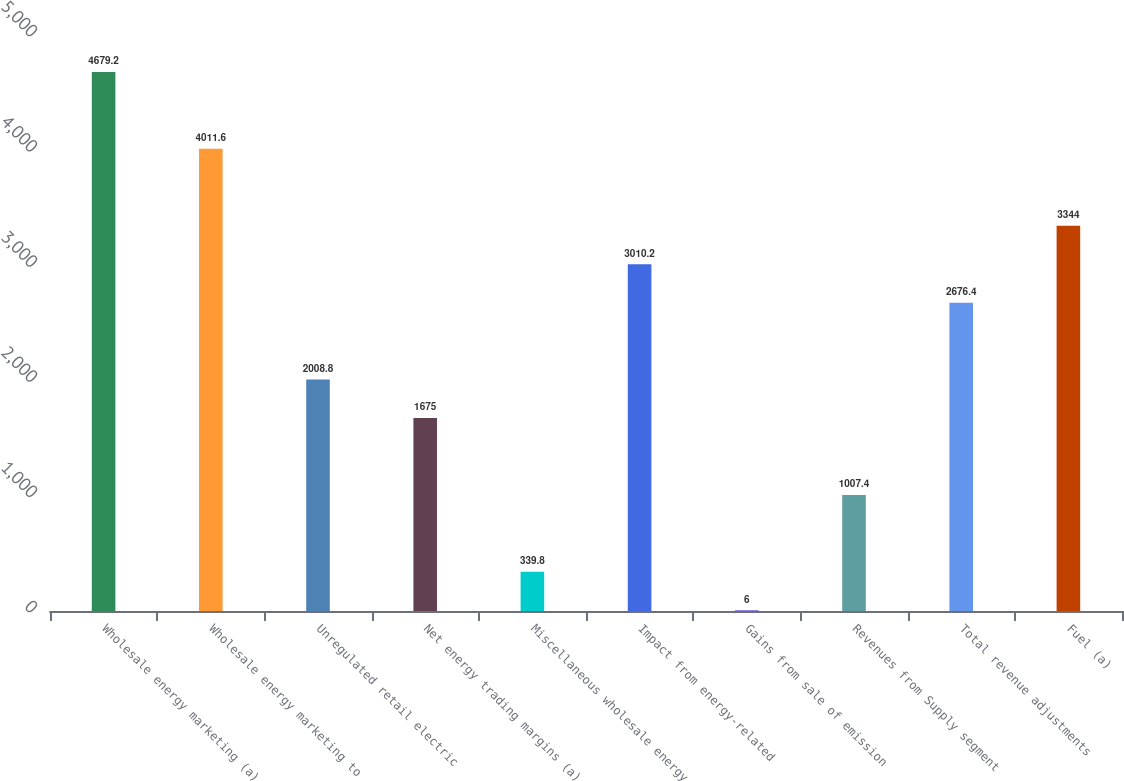<chart> <loc_0><loc_0><loc_500><loc_500><bar_chart><fcel>Wholesale energy marketing (a)<fcel>Wholesale energy marketing to<fcel>Unregulated retail electric<fcel>Net energy trading margins (a)<fcel>Miscellaneous wholesale energy<fcel>Impact from energy-related<fcel>Gains from sale of emission<fcel>Revenues from Supply segment<fcel>Total revenue adjustments<fcel>Fuel (a)<nl><fcel>4679.2<fcel>4011.6<fcel>2008.8<fcel>1675<fcel>339.8<fcel>3010.2<fcel>6<fcel>1007.4<fcel>2676.4<fcel>3344<nl></chart> 